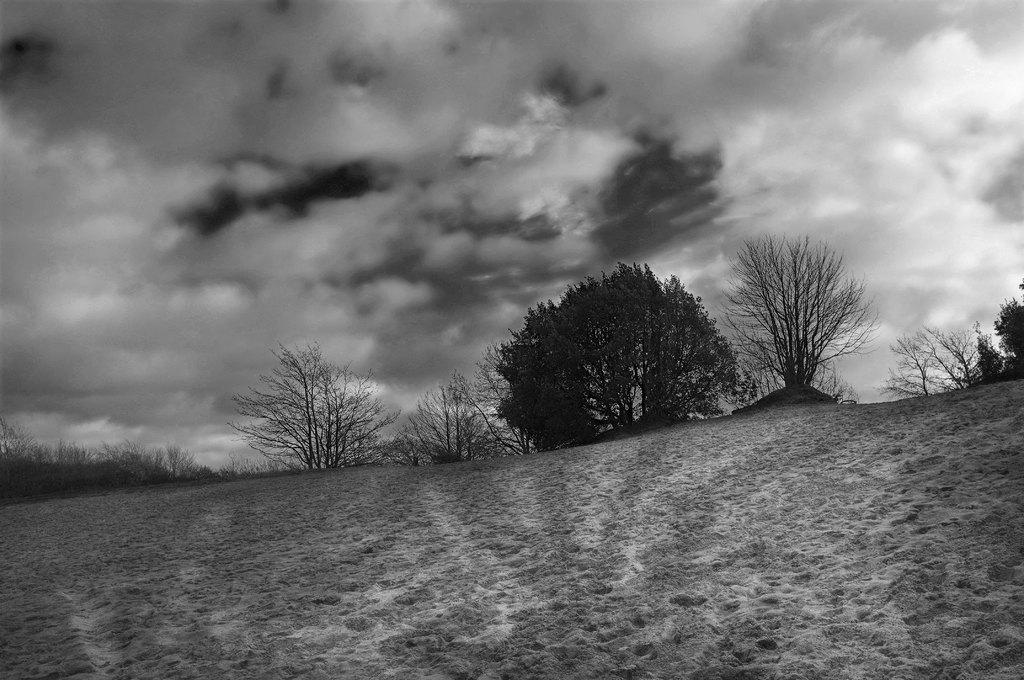What is the color scheme of the image? The image is black and white. What type of vegetation can be seen in the background? There are trees on the land in the background. What part of the natural environment is visible in the image? The sky is visible in the image. What can be observed in the sky? Clouds are present in the sky. What type of fuel is being used by the trees in the image? There is no mention of fuel in the image, as it features trees and clouds in a black and white setting. 